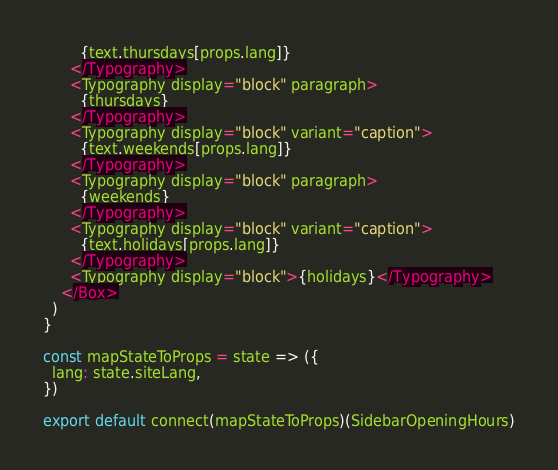<code> <loc_0><loc_0><loc_500><loc_500><_JavaScript_>        {text.thursdays[props.lang]}
      </Typography>
      <Typography display="block" paragraph>
        {thursdays}
      </Typography>
      <Typography display="block" variant="caption">
        {text.weekends[props.lang]}
      </Typography>
      <Typography display="block" paragraph>
        {weekends}
      </Typography>
      <Typography display="block" variant="caption">
        {text.holidays[props.lang]}
      </Typography>
      <Typography display="block">{holidays}</Typography>
    </Box>
  )
}

const mapStateToProps = state => ({
  lang: state.siteLang,
})

export default connect(mapStateToProps)(SidebarOpeningHours)
</code> 